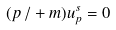<formula> <loc_0><loc_0><loc_500><loc_500>( p \, / + m ) u _ { p } ^ { s } = 0</formula> 